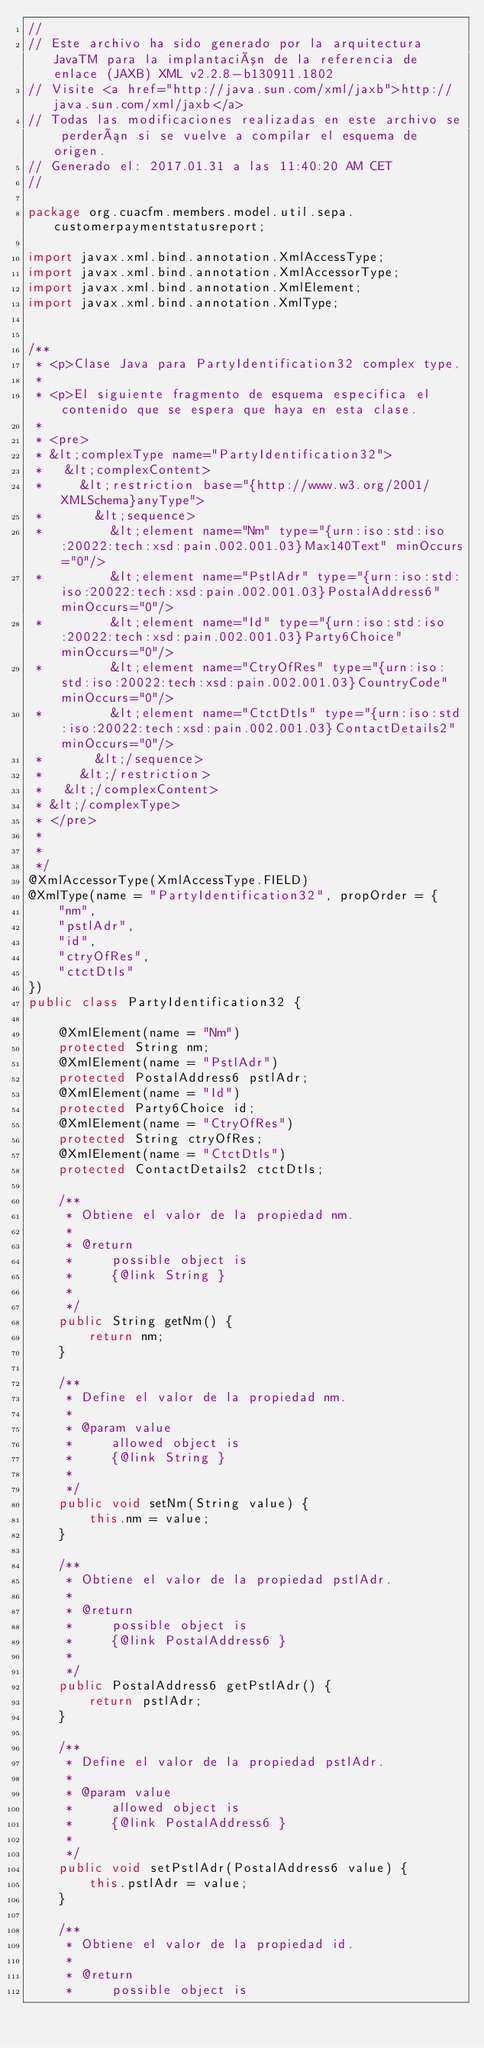<code> <loc_0><loc_0><loc_500><loc_500><_Java_>//
// Este archivo ha sido generado por la arquitectura JavaTM para la implantación de la referencia de enlace (JAXB) XML v2.2.8-b130911.1802 
// Visite <a href="http://java.sun.com/xml/jaxb">http://java.sun.com/xml/jaxb</a> 
// Todas las modificaciones realizadas en este archivo se perderán si se vuelve a compilar el esquema de origen. 
// Generado el: 2017.01.31 a las 11:40:20 AM CET 
//

package org.cuacfm.members.model.util.sepa.customerpaymentstatusreport;

import javax.xml.bind.annotation.XmlAccessType;
import javax.xml.bind.annotation.XmlAccessorType;
import javax.xml.bind.annotation.XmlElement;
import javax.xml.bind.annotation.XmlType;


/**
 * <p>Clase Java para PartyIdentification32 complex type.
 * 
 * <p>El siguiente fragmento de esquema especifica el contenido que se espera que haya en esta clase.
 * 
 * <pre>
 * &lt;complexType name="PartyIdentification32">
 *   &lt;complexContent>
 *     &lt;restriction base="{http://www.w3.org/2001/XMLSchema}anyType">
 *       &lt;sequence>
 *         &lt;element name="Nm" type="{urn:iso:std:iso:20022:tech:xsd:pain.002.001.03}Max140Text" minOccurs="0"/>
 *         &lt;element name="PstlAdr" type="{urn:iso:std:iso:20022:tech:xsd:pain.002.001.03}PostalAddress6" minOccurs="0"/>
 *         &lt;element name="Id" type="{urn:iso:std:iso:20022:tech:xsd:pain.002.001.03}Party6Choice" minOccurs="0"/>
 *         &lt;element name="CtryOfRes" type="{urn:iso:std:iso:20022:tech:xsd:pain.002.001.03}CountryCode" minOccurs="0"/>
 *         &lt;element name="CtctDtls" type="{urn:iso:std:iso:20022:tech:xsd:pain.002.001.03}ContactDetails2" minOccurs="0"/>
 *       &lt;/sequence>
 *     &lt;/restriction>
 *   &lt;/complexContent>
 * &lt;/complexType>
 * </pre>
 * 
 * 
 */
@XmlAccessorType(XmlAccessType.FIELD)
@XmlType(name = "PartyIdentification32", propOrder = {
    "nm",
    "pstlAdr",
    "id",
    "ctryOfRes",
    "ctctDtls"
})
public class PartyIdentification32 {

    @XmlElement(name = "Nm")
    protected String nm;
    @XmlElement(name = "PstlAdr")
    protected PostalAddress6 pstlAdr;
    @XmlElement(name = "Id")
    protected Party6Choice id;
    @XmlElement(name = "CtryOfRes")
    protected String ctryOfRes;
    @XmlElement(name = "CtctDtls")
    protected ContactDetails2 ctctDtls;

    /**
     * Obtiene el valor de la propiedad nm.
     * 
     * @return
     *     possible object is
     *     {@link String }
     *     
     */
    public String getNm() {
        return nm;
    }

    /**
     * Define el valor de la propiedad nm.
     * 
     * @param value
     *     allowed object is
     *     {@link String }
     *     
     */
    public void setNm(String value) {
        this.nm = value;
    }

    /**
     * Obtiene el valor de la propiedad pstlAdr.
     * 
     * @return
     *     possible object is
     *     {@link PostalAddress6 }
     *     
     */
    public PostalAddress6 getPstlAdr() {
        return pstlAdr;
    }

    /**
     * Define el valor de la propiedad pstlAdr.
     * 
     * @param value
     *     allowed object is
     *     {@link PostalAddress6 }
     *     
     */
    public void setPstlAdr(PostalAddress6 value) {
        this.pstlAdr = value;
    }

    /**
     * Obtiene el valor de la propiedad id.
     * 
     * @return
     *     possible object is</code> 